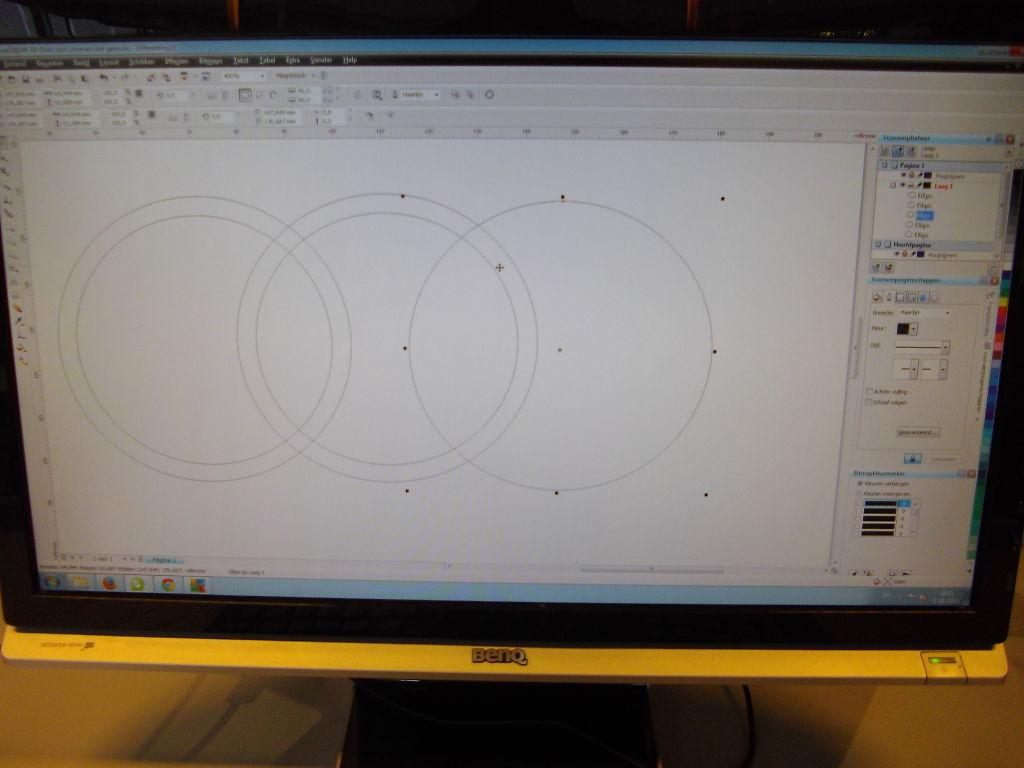What is displayed on the monitor screen in the image? There are circles and dots on the monitor screen. Where is the monitor located in the image? The monitor is placed on a table. What type of treatment is being administered to the circles on the monitor screen? There is no treatment being administered to the circles on the monitor screen, as they are part of a digital image and not living organisms. 